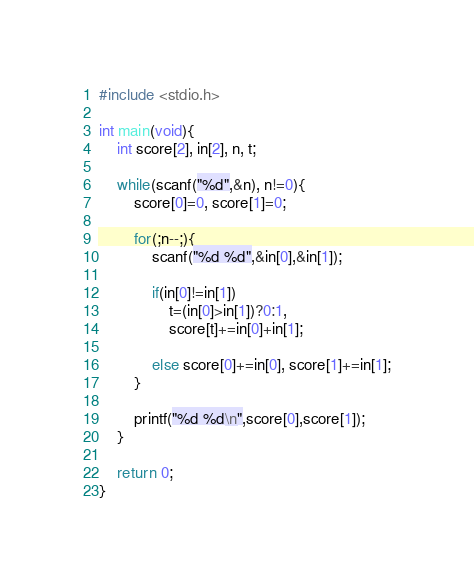<code> <loc_0><loc_0><loc_500><loc_500><_C_>#include <stdio.h>

int main(void){
	int score[2], in[2], n, t;
	
	while(scanf("%d",&n), n!=0){
		score[0]=0, score[1]=0;
		
		for(;n--;){
			scanf("%d %d",&in[0],&in[1]);
		
			if(in[0]!=in[1])
				t=(in[0]>in[1])?0:1,
				score[t]+=in[0]+in[1];
		
			else score[0]+=in[0], score[1]+=in[1];
		}
	
		printf("%d %d\n",score[0],score[1]);
	}
	
	return 0;
}</code> 